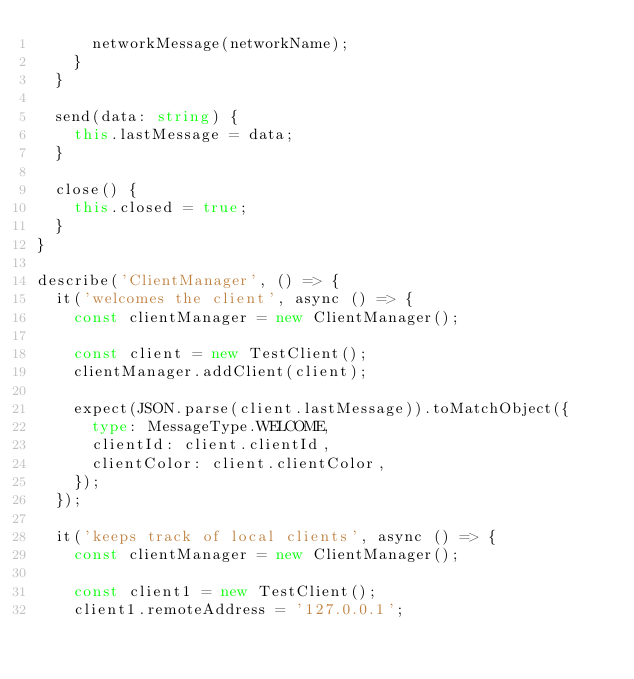<code> <loc_0><loc_0><loc_500><loc_500><_TypeScript_>      networkMessage(networkName);
    }
  }

  send(data: string) {
    this.lastMessage = data;
  }

  close() {
    this.closed = true;
  }
}

describe('ClientManager', () => {
  it('welcomes the client', async () => {
    const clientManager = new ClientManager();

    const client = new TestClient();
    clientManager.addClient(client);

    expect(JSON.parse(client.lastMessage)).toMatchObject({
      type: MessageType.WELCOME,
      clientId: client.clientId,
      clientColor: client.clientColor,
    });
  });

  it('keeps track of local clients', async () => {
    const clientManager = new ClientManager();

    const client1 = new TestClient();
    client1.remoteAddress = '127.0.0.1';</code> 